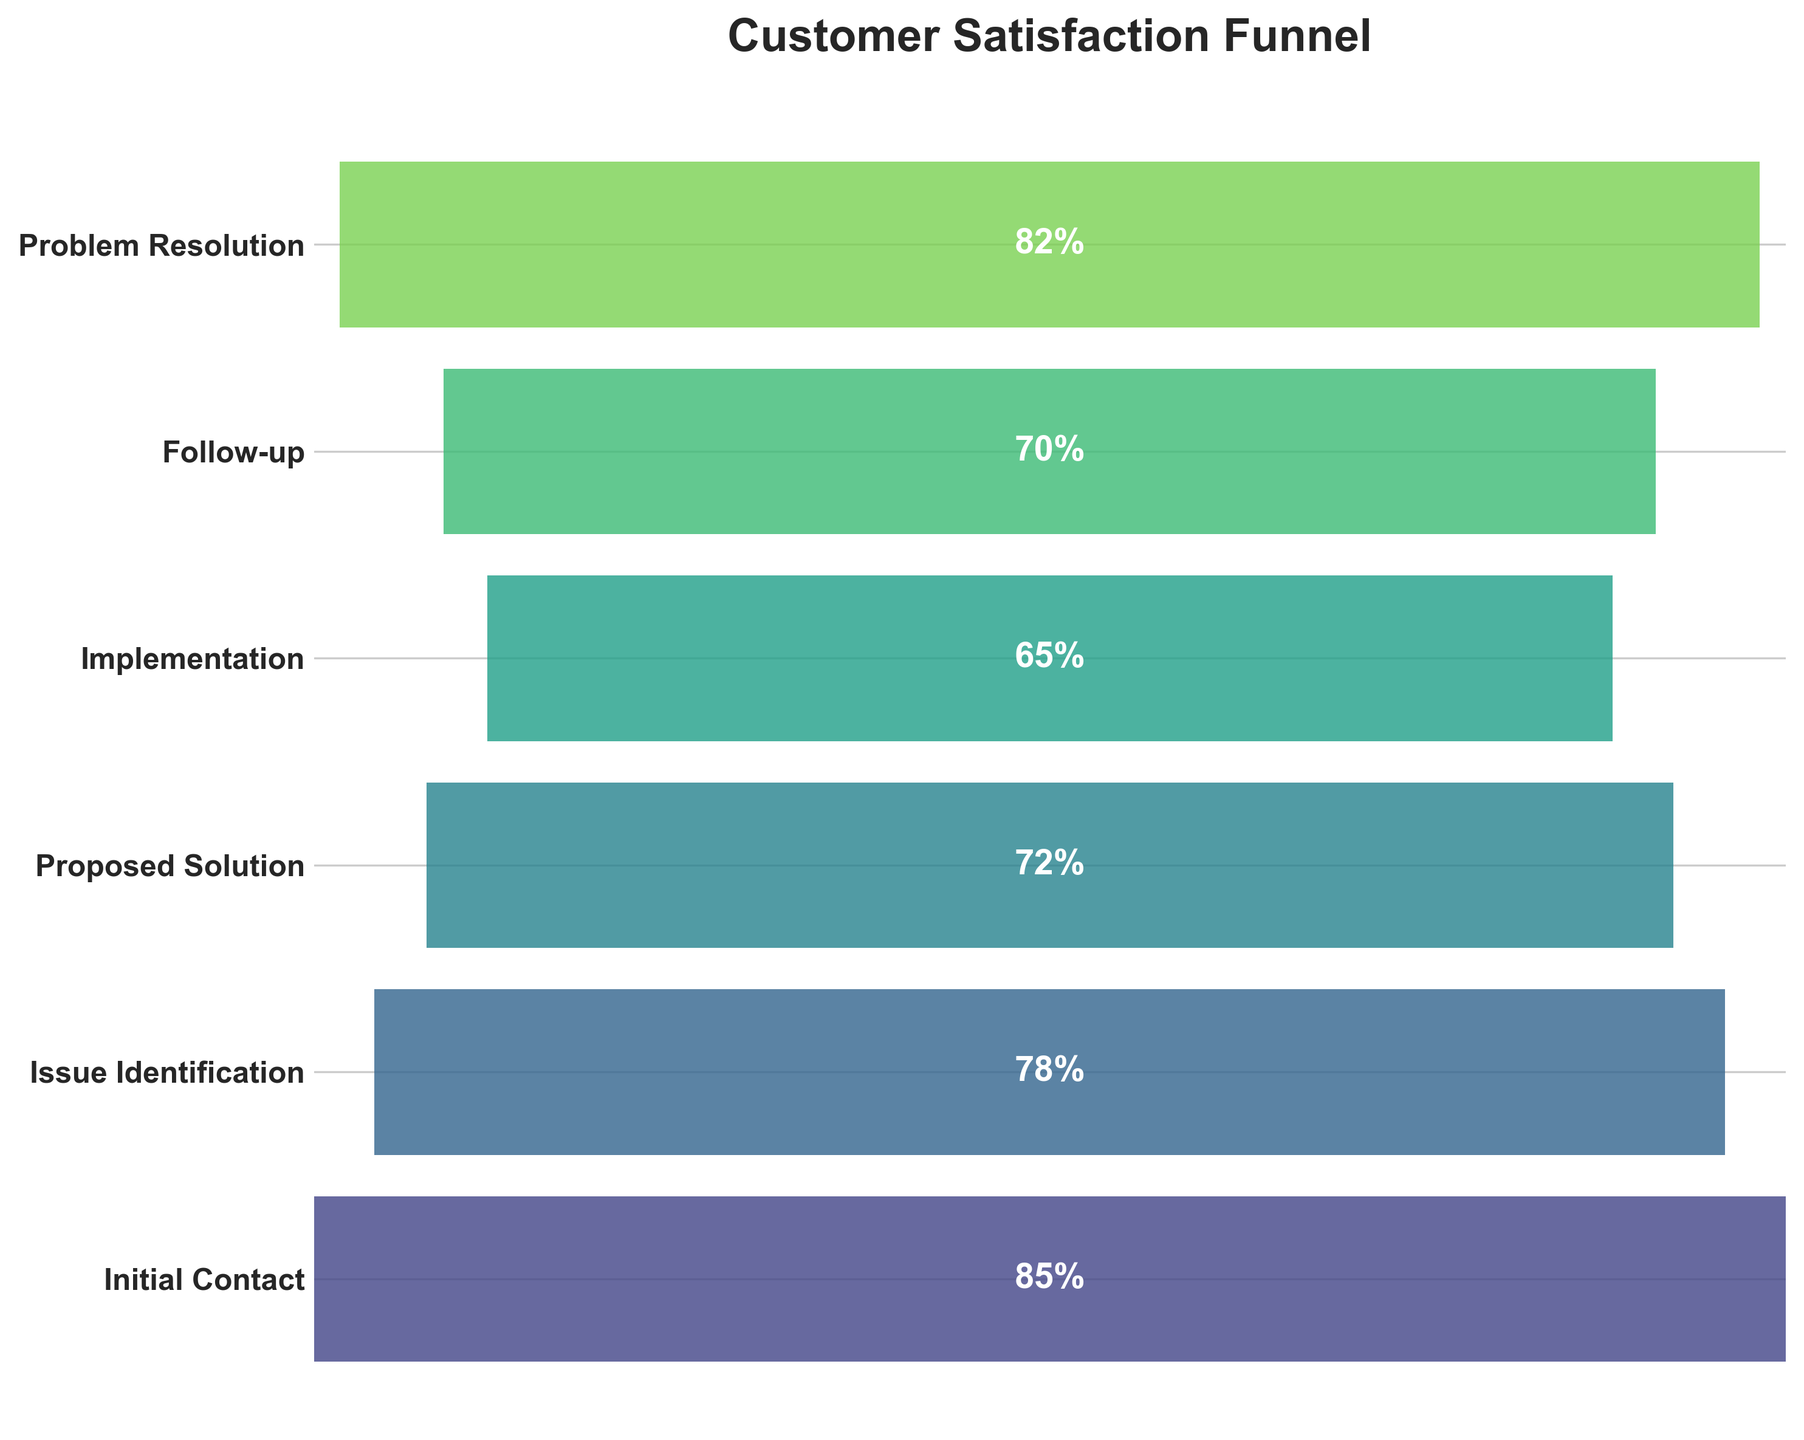What is the title of the figure? The title is displayed at the top of the figure.
Answer: Customer Satisfaction Funnel Which phase has the highest satisfaction percentage? The figure shows satisfaction percentages for each phase. The highest percentage is connected to "Initial Contact."
Answer: Initial Contact How many phases are presented in the funnel chart? Each phase is represented by a horizontal bar in the figure. Counting these bars gives the total phases.
Answer: Six In which phase do satisfaction percentages decrease to their lowest value? By comparing the lengths of the bars, the shortest bar represents the lowest value, which is for "Implementation."
Answer: Implementation What is the satisfaction percentage of the "Follow-up" phase? Locate the "Follow-up" phase on the left and read the associated percentage.
Answer: 70% What is the difference in satisfaction percentage between "Initial Contact" and "Implementation"? Subtract the satisfaction percentage of "Implementation" from "Initial Contact": 85% - 65%.
Answer: 20% Which phase has a higher satisfaction percentage, "Issue Identification" or "Problem Resolution"? Compare the lengths of the bars for both phases; "Problem Resolution" has a longer bar.
Answer: Problem Resolution What is the average satisfaction percentage across all the phases? Add satisfaction percentages of all phases and divide by the number of phases: (85% + 78% + 72% + 65% + 70% + 82%) / 6.
Answer: 75.33% How does satisfaction change from "Proposed Solution" to "Implementation"? Compare the bars from "Proposed Solution" and "Implementation": 72% to 65%, showing a decrease.
Answer: Decreases Is the satisfaction percentage at the "Follow-up" phase greater compared to the "Proposed Solution" phase? Compare the satisfaction percentages: 70% for "Follow-up" vs. 72% for "Proposed Solution."
Answer: No 